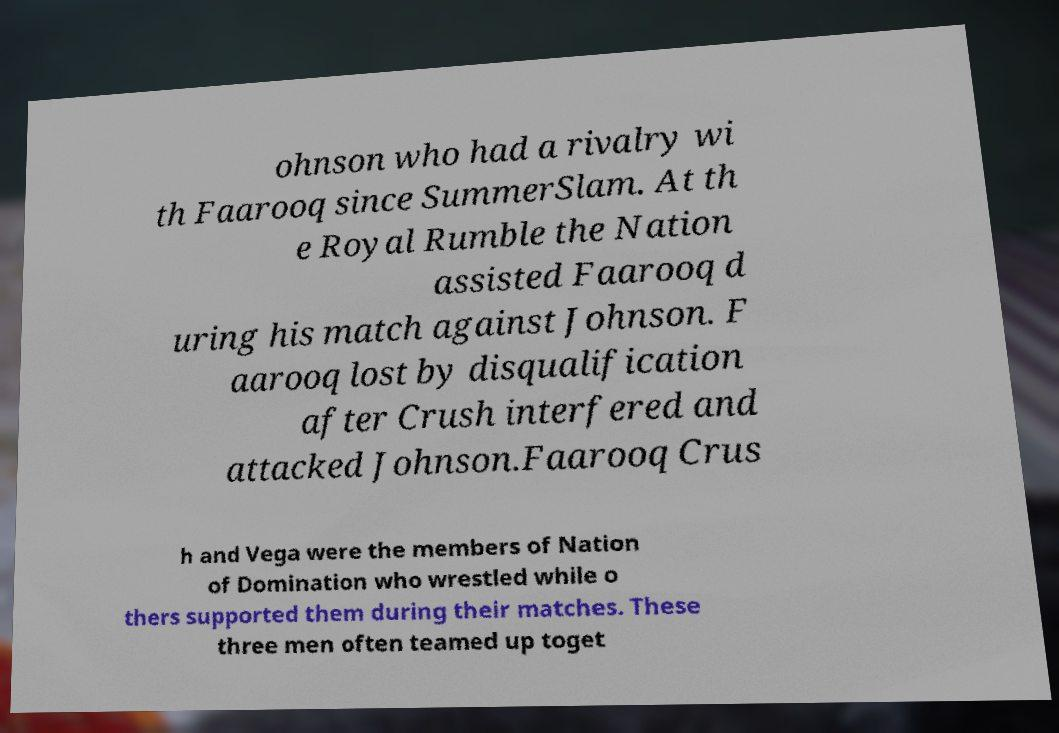Can you accurately transcribe the text from the provided image for me? ohnson who had a rivalry wi th Faarooq since SummerSlam. At th e Royal Rumble the Nation assisted Faarooq d uring his match against Johnson. F aarooq lost by disqualification after Crush interfered and attacked Johnson.Faarooq Crus h and Vega were the members of Nation of Domination who wrestled while o thers supported them during their matches. These three men often teamed up toget 